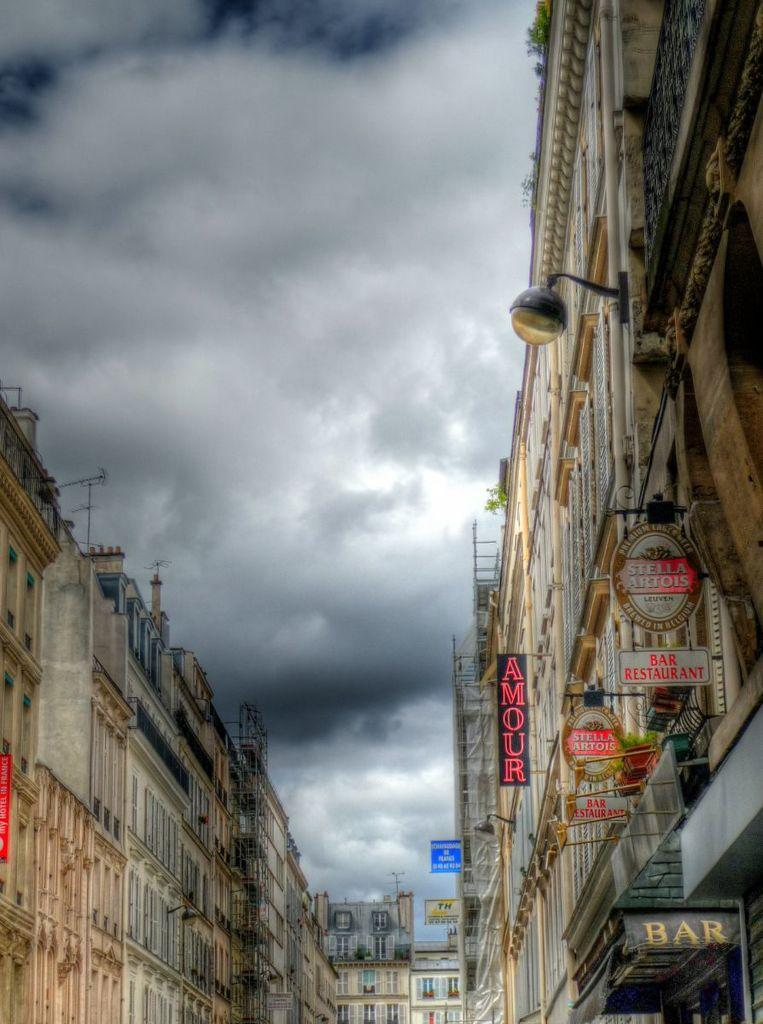What type of structures are present in the image? There are buildings in the image. What is attached to the walls of the buildings? There are boards and text attached to the walls of the buildings. Are there any additional features on the buildings? Yes, there is a light attached to one of the buildings. What can be seen in the background of the image? The sky is visible at the top of the image. What type of voyage is depicted in the image? There is no voyage depicted in the image; it features buildings with boards and text attached to the walls, a light, and a visible sky. Can you hear the bells ringing in the image? There are no bells present in the image, so it is not possible to hear them ringing. 